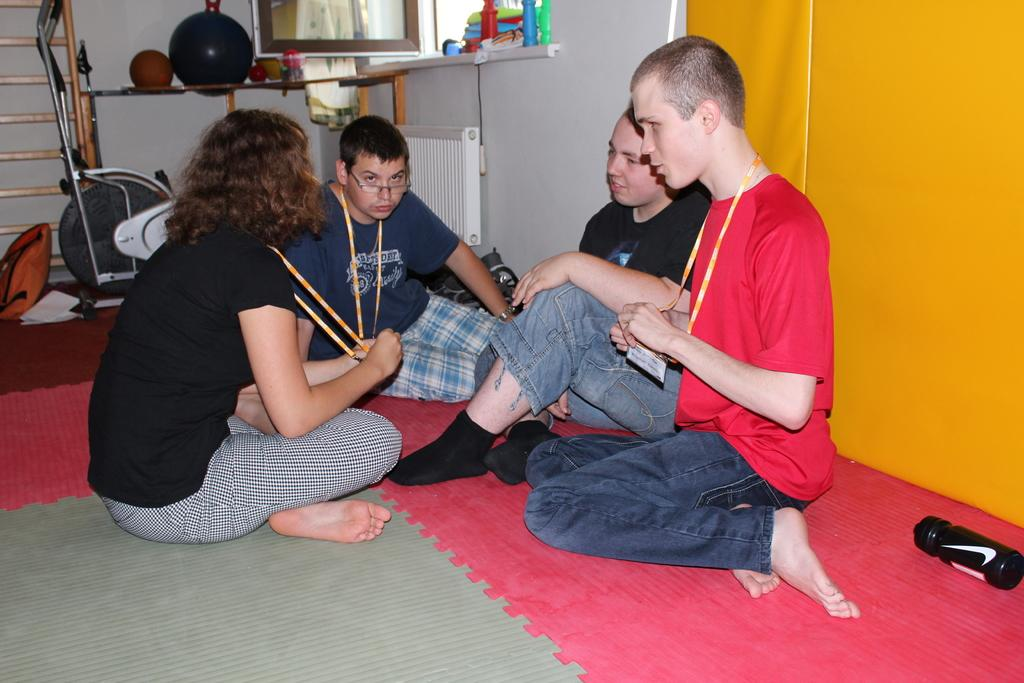What type of floor covering is present in the image? The floor has a carpet. What object is placed on the carpet? There is a bottle on the carpet. How many people are sitting on the ground in the image? Four people are sitting on the ground. What other items can be seen in the image besides the people and the bottle? There are balls and unspecified things in the image, as well as gym equipment. What is the cause of the argument between the people in the image? There is no argument present in the image; the people are sitting on the ground. Is there a fire visible in the image? No, there is no fire present in the image. Can you see any bees in the image? No, there are no bees present in the image. 